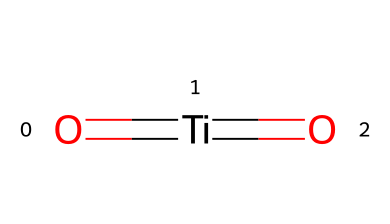what is the central atom in this chemical structure? The chemical structure shows a titanium atom (Ti) as the central atom, indicated by the presence of the bond with oxygen and its position in the structure.
Answer: titanium how many oxygen atoms are present in this chemical? The SMILES representation shows two oxygen atoms connected to the titanium atom, indicating that there are two oxygen atoms in the chemical structure.
Answer: two what type of bonds are formed in this structure? The structure contains double bonds between the titanium and each of the oxygen atoms, as suggested by the notation "O=[Ti]=O", indicating that both bonds are double bonds.
Answer: double bonds what is the overall charge of this chemical? The provided structure does not indicate any formal charges on the atoms; therefore, it can be inferred that the overall charge of the molecule is neutral.
Answer: neutral how does this chemical relate to enhancing the performance of sports equipment? Titanium dioxide, as represented by the chemical structure, is often used in coatings due to its durability and resistance to corrosion, making it beneficial for sports equipment.
Answer: durability what is the significance of titanium in sports equipment coatings? Titanium is known for its strength-to-weight ratio and corrosion resistance, which enhances the performance and longevity of sports equipment when used in coatings.
Answer: strength-to-weight ratio 